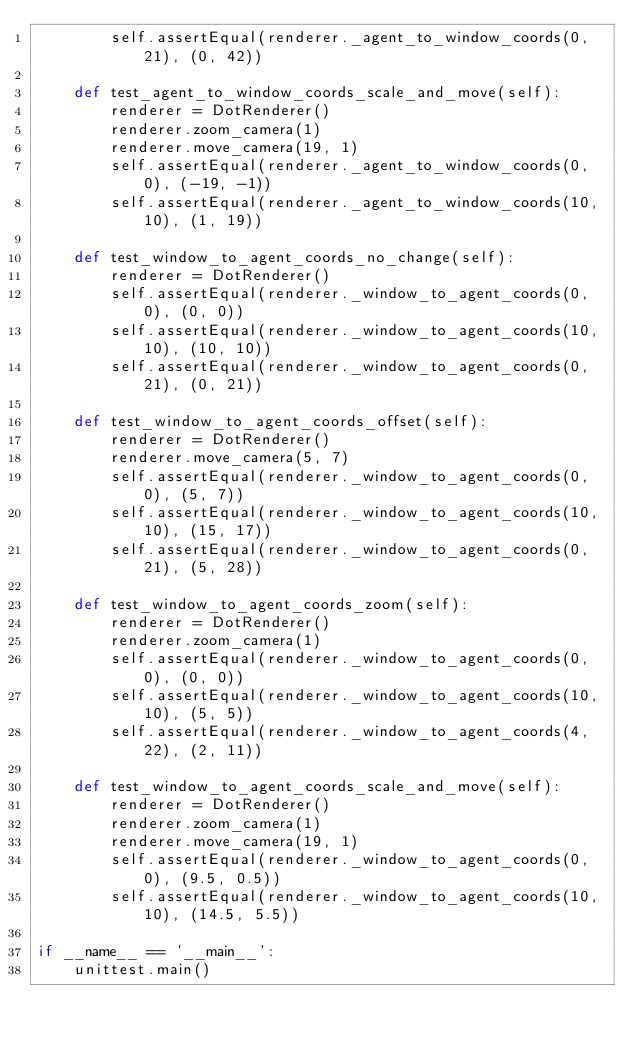Convert code to text. <code><loc_0><loc_0><loc_500><loc_500><_Python_>        self.assertEqual(renderer._agent_to_window_coords(0, 21), (0, 42))

    def test_agent_to_window_coords_scale_and_move(self):
        renderer = DotRenderer()
        renderer.zoom_camera(1)
        renderer.move_camera(19, 1)
        self.assertEqual(renderer._agent_to_window_coords(0, 0), (-19, -1))
        self.assertEqual(renderer._agent_to_window_coords(10, 10), (1, 19))

    def test_window_to_agent_coords_no_change(self):
        renderer = DotRenderer()
        self.assertEqual(renderer._window_to_agent_coords(0, 0), (0, 0))
        self.assertEqual(renderer._window_to_agent_coords(10, 10), (10, 10))
        self.assertEqual(renderer._window_to_agent_coords(0, 21), (0, 21))

    def test_window_to_agent_coords_offset(self):
        renderer = DotRenderer()
        renderer.move_camera(5, 7)
        self.assertEqual(renderer._window_to_agent_coords(0, 0), (5, 7))
        self.assertEqual(renderer._window_to_agent_coords(10, 10), (15, 17))
        self.assertEqual(renderer._window_to_agent_coords(0, 21), (5, 28))

    def test_window_to_agent_coords_zoom(self):
        renderer = DotRenderer()
        renderer.zoom_camera(1)
        self.assertEqual(renderer._window_to_agent_coords(0, 0), (0, 0))
        self.assertEqual(renderer._window_to_agent_coords(10, 10), (5, 5))
        self.assertEqual(renderer._window_to_agent_coords(4, 22), (2, 11))

    def test_window_to_agent_coords_scale_and_move(self):
        renderer = DotRenderer()
        renderer.zoom_camera(1)
        renderer.move_camera(19, 1)
        self.assertEqual(renderer._window_to_agent_coords(0, 0), (9.5, 0.5))
        self.assertEqual(renderer._window_to_agent_coords(10, 10), (14.5, 5.5))

if __name__ == '__main__':
    unittest.main()
</code> 